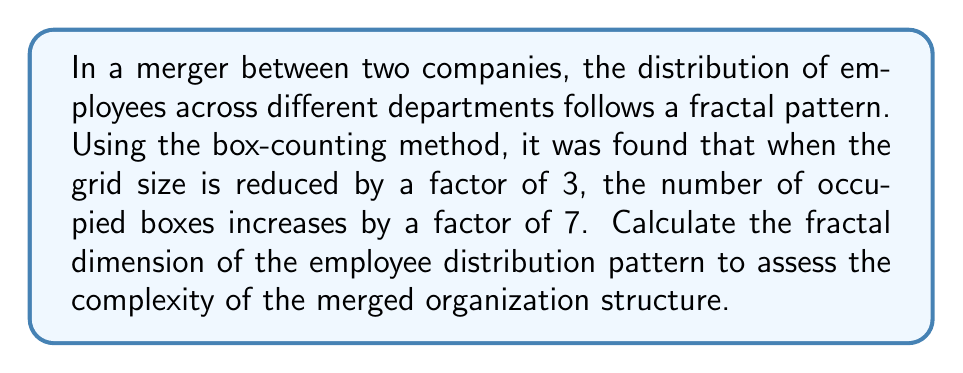Solve this math problem. To calculate the fractal dimension using the box-counting method, we use the following steps:

1. Recall the formula for fractal dimension (D) using the box-counting method:

   $$D = \frac{\log(N)}{\log(1/r)}$$

   where N is the factor by which the number of occupied boxes increases, and r is the factor by which the grid size is reduced.

2. In this case:
   - N = 7 (number of occupied boxes increases by a factor of 7)
   - r = 1/3 (grid size is reduced by a factor of 3)

3. Substitute these values into the formula:

   $$D = \frac{\log(7)}{\log(3)}$$

4. Calculate the logarithms:
   
   $$D = \frac{0.8450980400}{0.4771212547}$$

5. Perform the division:

   $$D \approx 1.7712$$

The fractal dimension of 1.7712 indicates a complex distribution pattern that falls between a line (dimension 1) and a plane (dimension 2), suggesting a highly intricate organizational structure in the merged company.
Answer: $$1.7712$$ 